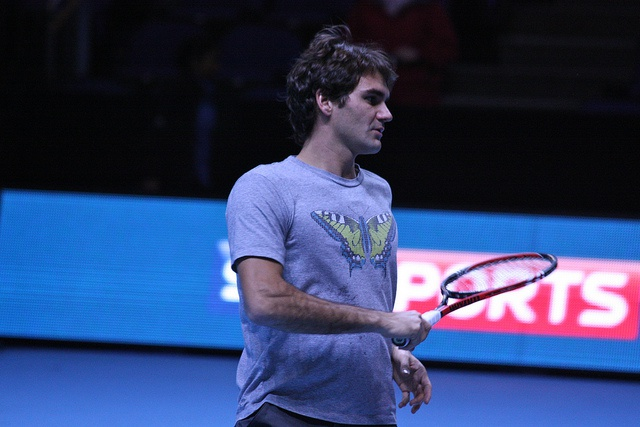Describe the objects in this image and their specific colors. I can see people in black, blue, navy, and lightblue tones and tennis racket in black, lavender, and violet tones in this image. 